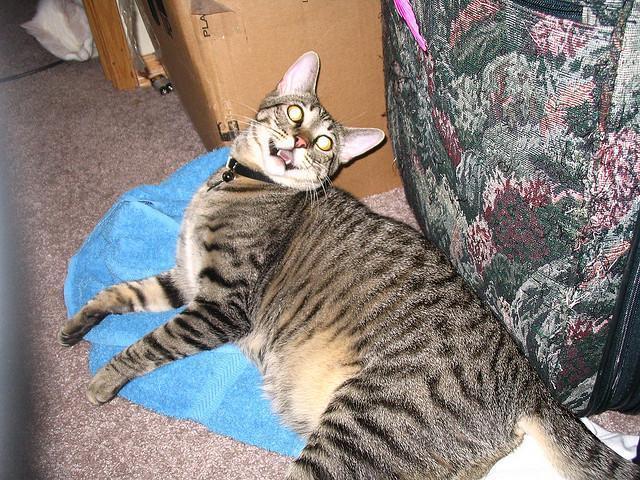How many cats can you see?
Give a very brief answer. 2. 